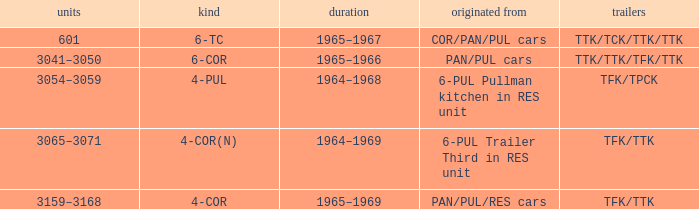Name the formed that has type of 4-cor PAN/PUL/RES cars. 